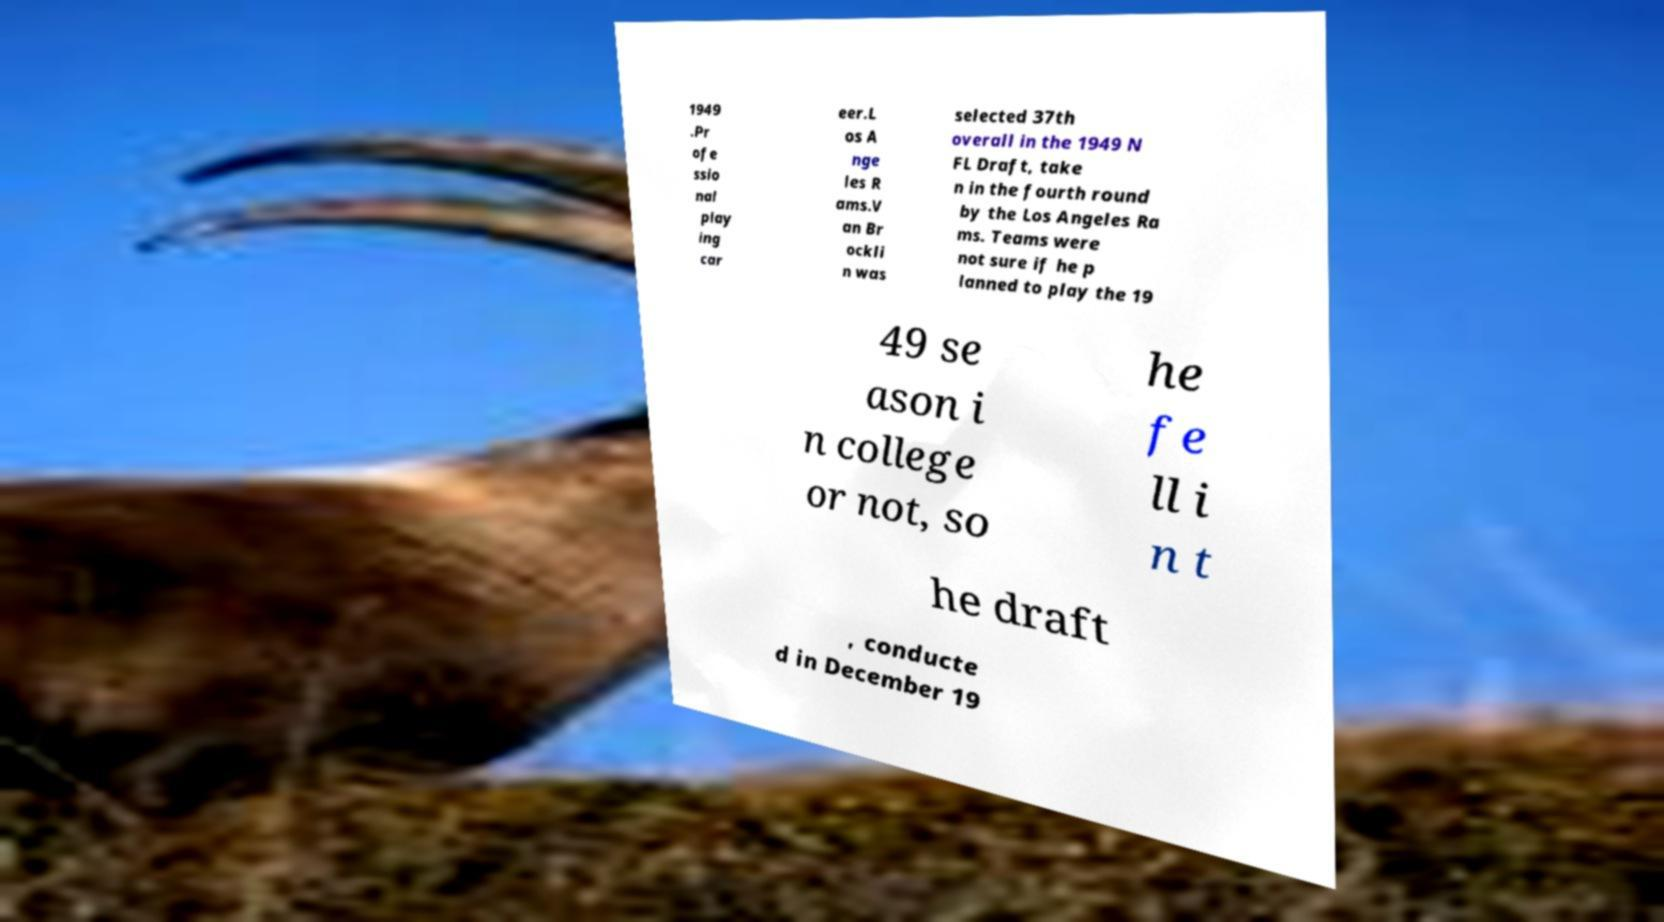For documentation purposes, I need the text within this image transcribed. Could you provide that? 1949 .Pr ofe ssio nal play ing car eer.L os A nge les R ams.V an Br ockli n was selected 37th overall in the 1949 N FL Draft, take n in the fourth round by the Los Angeles Ra ms. Teams were not sure if he p lanned to play the 19 49 se ason i n college or not, so he fe ll i n t he draft , conducte d in December 19 